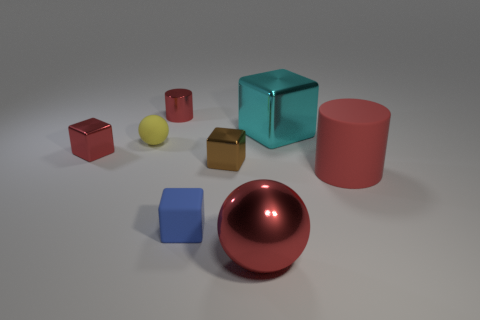What number of tiny objects are brown matte things or red blocks?
Offer a terse response. 1. Is the number of blue things greater than the number of metallic blocks?
Offer a very short reply. No. There is a cylinder in front of the rubber thing behind the red rubber object; how many tiny red metallic cubes are behind it?
Offer a very short reply. 1. What is the shape of the blue rubber object?
Your answer should be compact. Cube. What number of other things are there of the same material as the large sphere
Offer a very short reply. 4. Do the rubber sphere and the red shiny cube have the same size?
Your answer should be compact. Yes. There is a small object on the left side of the yellow thing; what shape is it?
Your answer should be compact. Cube. There is a big shiny thing that is behind the metal object in front of the tiny brown thing; what color is it?
Your response must be concise. Cyan. Is the shape of the small shiny thing that is behind the yellow rubber sphere the same as the red object that is to the right of the big red metal sphere?
Offer a very short reply. Yes. There is a brown thing that is the same size as the blue thing; what is its shape?
Your response must be concise. Cube. 